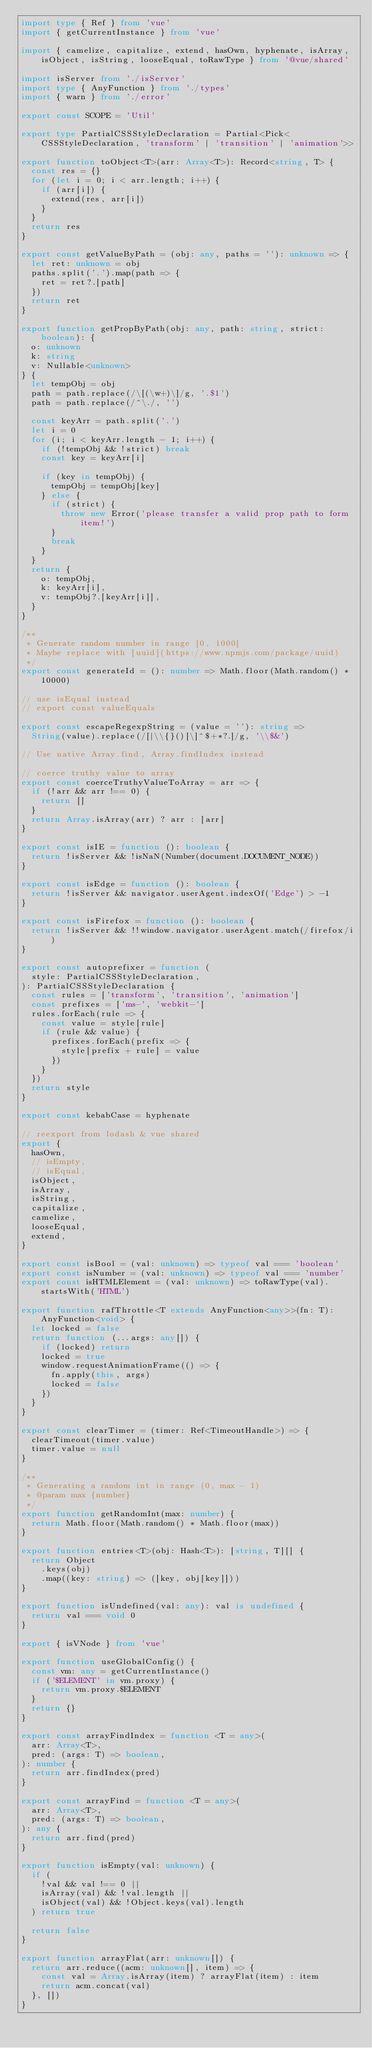Convert code to text. <code><loc_0><loc_0><loc_500><loc_500><_TypeScript_>import type { Ref } from 'vue'
import { getCurrentInstance } from 'vue'

import { camelize, capitalize, extend, hasOwn, hyphenate, isArray, isObject, isString, looseEqual, toRawType } from '@vue/shared'

import isServer from './isServer'
import type { AnyFunction } from './types'
import { warn } from './error'

export const SCOPE = 'Util'

export type PartialCSSStyleDeclaration = Partial<Pick<CSSStyleDeclaration, 'transform' | 'transition' | 'animation'>>

export function toObject<T>(arr: Array<T>): Record<string, T> {
  const res = {}
  for (let i = 0; i < arr.length; i++) {
    if (arr[i]) {
      extend(res, arr[i])
    }
  }
  return res
}

export const getValueByPath = (obj: any, paths = ''): unknown => {
  let ret: unknown = obj
  paths.split('.').map(path => {
    ret = ret?.[path]
  })
  return ret
}

export function getPropByPath(obj: any, path: string, strict: boolean): {
  o: unknown
  k: string
  v: Nullable<unknown>
} {
  let tempObj = obj
  path = path.replace(/\[(\w+)\]/g, '.$1')
  path = path.replace(/^\./, '')

  const keyArr = path.split('.')
  let i = 0
  for (i; i < keyArr.length - 1; i++) {
    if (!tempObj && !strict) break
    const key = keyArr[i]

    if (key in tempObj) {
      tempObj = tempObj[key]
    } else {
      if (strict) {
        throw new Error('please transfer a valid prop path to form item!')
      }
      break
    }
  }
  return {
    o: tempObj,
    k: keyArr[i],
    v: tempObj?.[keyArr[i]],
  }
}

/**
 * Generate random number in range [0, 1000]
 * Maybe replace with [uuid](https://www.npmjs.com/package/uuid)
 */
export const generateId = (): number => Math.floor(Math.random() * 10000)

// use isEqual instead
// export const valueEquals

export const escapeRegexpString = (value = ''): string =>
  String(value).replace(/[|\\{}()[\]^$+*?.]/g, '\\$&')

// Use native Array.find, Array.findIndex instead

// coerce truthy value to array
export const coerceTruthyValueToArray = arr => {
  if (!arr && arr !== 0) {
    return []
  }
  return Array.isArray(arr) ? arr : [arr]
}

export const isIE = function (): boolean {
  return !isServer && !isNaN(Number(document.DOCUMENT_NODE))
}

export const isEdge = function (): boolean {
  return !isServer && navigator.userAgent.indexOf('Edge') > -1
}

export const isFirefox = function (): boolean {
  return !isServer && !!window.navigator.userAgent.match(/firefox/i)
}

export const autoprefixer = function (
  style: PartialCSSStyleDeclaration,
): PartialCSSStyleDeclaration {
  const rules = ['transform', 'transition', 'animation']
  const prefixes = ['ms-', 'webkit-']
  rules.forEach(rule => {
    const value = style[rule]
    if (rule && value) {
      prefixes.forEach(prefix => {
        style[prefix + rule] = value
      })
    }
  })
  return style
}

export const kebabCase = hyphenate

// reexport from lodash & vue shared
export {
  hasOwn,
  // isEmpty,
  // isEqual,
  isObject,
  isArray,
  isString,
  capitalize,
  camelize,
  looseEqual,
  extend,
}

export const isBool = (val: unknown) => typeof val === 'boolean'
export const isNumber = (val: unknown) => typeof val === 'number'
export const isHTMLElement = (val: unknown) => toRawType(val).startsWith('HTML')

export function rafThrottle<T extends AnyFunction<any>>(fn: T): AnyFunction<void> {
  let locked = false
  return function (...args: any[]) {
    if (locked) return
    locked = true
    window.requestAnimationFrame(() => {
      fn.apply(this, args)
      locked = false
    })
  }
}

export const clearTimer = (timer: Ref<TimeoutHandle>) => {
  clearTimeout(timer.value)
  timer.value = null
}

/**
 * Generating a random int in range (0, max - 1)
 * @param max {number}
 */
export function getRandomInt(max: number) {
  return Math.floor(Math.random() * Math.floor(max))
}

export function entries<T>(obj: Hash<T>): [string, T][] {
  return Object
    .keys(obj)
    .map((key: string) => ([key, obj[key]]))
}

export function isUndefined(val: any): val is undefined {
  return val === void 0
}

export { isVNode } from 'vue'

export function useGlobalConfig() {
  const vm: any = getCurrentInstance()
  if ('$ELEMENT' in vm.proxy) {
    return vm.proxy.$ELEMENT
  }
  return {}
}

export const arrayFindIndex = function <T = any>(
  arr: Array<T>,
  pred: (args: T) => boolean,
): number {
  return arr.findIndex(pred)
}

export const arrayFind = function <T = any>(
  arr: Array<T>,
  pred: (args: T) => boolean,
): any {
  return arr.find(pred)
}

export function isEmpty(val: unknown) {
  if (
    !val && val !== 0 ||
    isArray(val) && !val.length ||
    isObject(val) && !Object.keys(val).length
  ) return true

  return false
}

export function arrayFlat(arr: unknown[]) {
  return arr.reduce((acm: unknown[], item) => {
    const val = Array.isArray(item) ? arrayFlat(item) : item
    return acm.concat(val)
  }, [])
}
</code> 